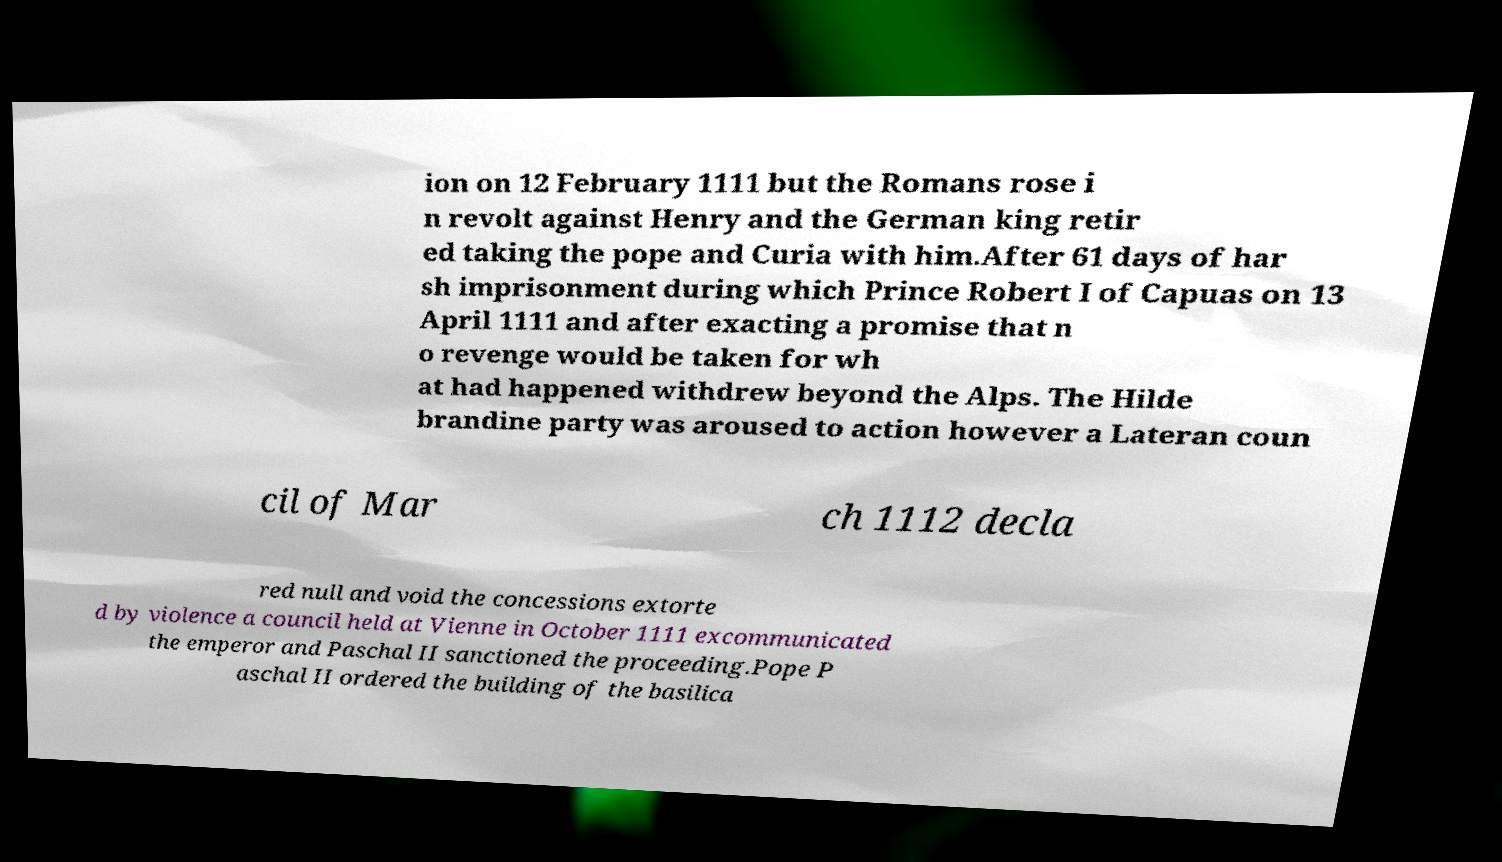Could you assist in decoding the text presented in this image and type it out clearly? ion on 12 February 1111 but the Romans rose i n revolt against Henry and the German king retir ed taking the pope and Curia with him.After 61 days of har sh imprisonment during which Prince Robert I of Capuas on 13 April 1111 and after exacting a promise that n o revenge would be taken for wh at had happened withdrew beyond the Alps. The Hilde brandine party was aroused to action however a Lateran coun cil of Mar ch 1112 decla red null and void the concessions extorte d by violence a council held at Vienne in October 1111 excommunicated the emperor and Paschal II sanctioned the proceeding.Pope P aschal II ordered the building of the basilica 